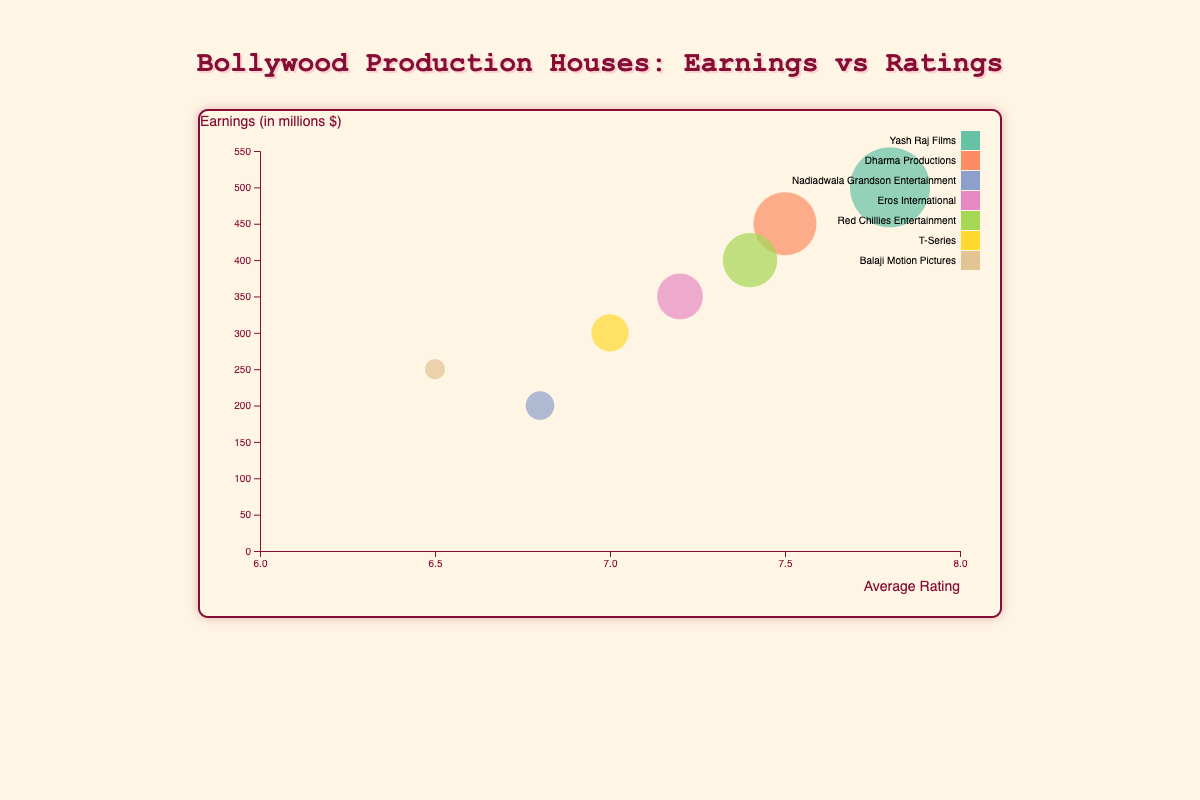What is the title of the figure? The title is usually found at the top, indicating the main subject of the figure.
Answer: Bollywood Production Houses: Earnings vs Ratings How many production houses are represented in the figure? The figure uses different circles for each production house. Count the bubbles or refer to the legend box.
Answer: 7 Which production house has the highest earnings? Look for the bubble that is highest on the vertical axis representing earnings. Hovering over bubbles can show more details.
Answer: Yash Raj Films What is the average rating for T-Series? Locate the bubble for T-Series. Hovering over it or looking at the horizontal position shows its average rating.
Answer: 7.0 Which production house has the most number of movies? Size of the bubble represents the number of movies. Identify the largest bubble.
Answer: Yash Raj Films Which production house has the lowest average rating? Check the bubbles closest to the left on the horizontal axis that represents the average rating. Hovering over these bubbles can confirm.
Answer: Balaji Motion Pictures Compare the earnings of Dharma Productions and Eros International. Which is higher? Note the vertical positions of the bubbles for these two production houses. The one that is higher has greater earnings.
Answer: Dharma Productions What is the combined number of movies for Yash Raj Films and Balaji Motion Pictures? Sum up the number of movies represented by the size of their respective bubbles.
Answer: 13 Which production house has an average rating closest to 7.5? Locate the bubbles by checking their positions on the horizontal axis near 7.5. Hovering over these can confirm the exact ratings.
Answer: Dharma Productions Is there a clear correlation between earnings and average rating in this figure? Observe the overall trend of bubbles from left to right. See if higher average ratings correspond to higher earnings.
Answer: No clear correlation 